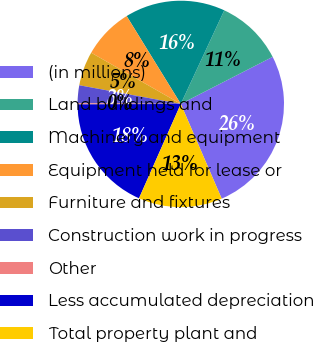Convert chart to OTSL. <chart><loc_0><loc_0><loc_500><loc_500><pie_chart><fcel>(in millions)<fcel>Land buildings and<fcel>Machinery and equipment<fcel>Equipment held for lease or<fcel>Furniture and fixtures<fcel>Construction work in progress<fcel>Other<fcel>Less accumulated depreciation<fcel>Total property plant and<nl><fcel>26.05%<fcel>10.54%<fcel>15.71%<fcel>7.95%<fcel>5.37%<fcel>2.78%<fcel>0.19%<fcel>18.29%<fcel>13.12%<nl></chart> 